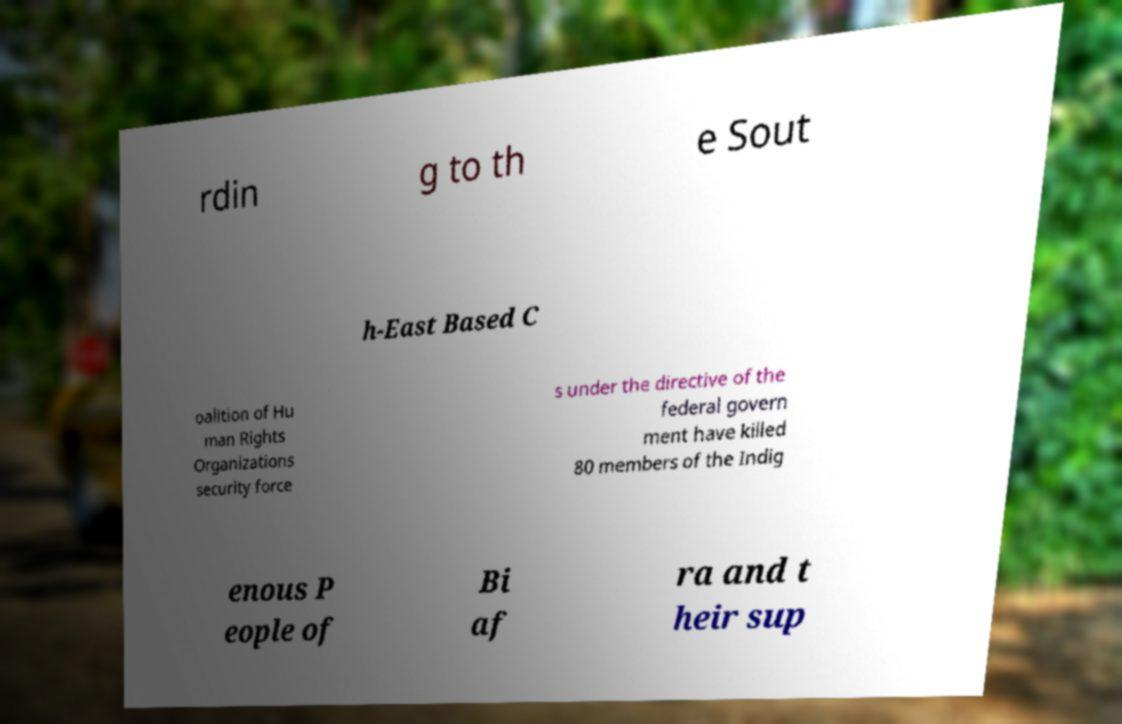Can you read and provide the text displayed in the image?This photo seems to have some interesting text. Can you extract and type it out for me? rdin g to th e Sout h-East Based C oalition of Hu man Rights Organizations security force s under the directive of the federal govern ment have killed 80 members of the Indig enous P eople of Bi af ra and t heir sup 